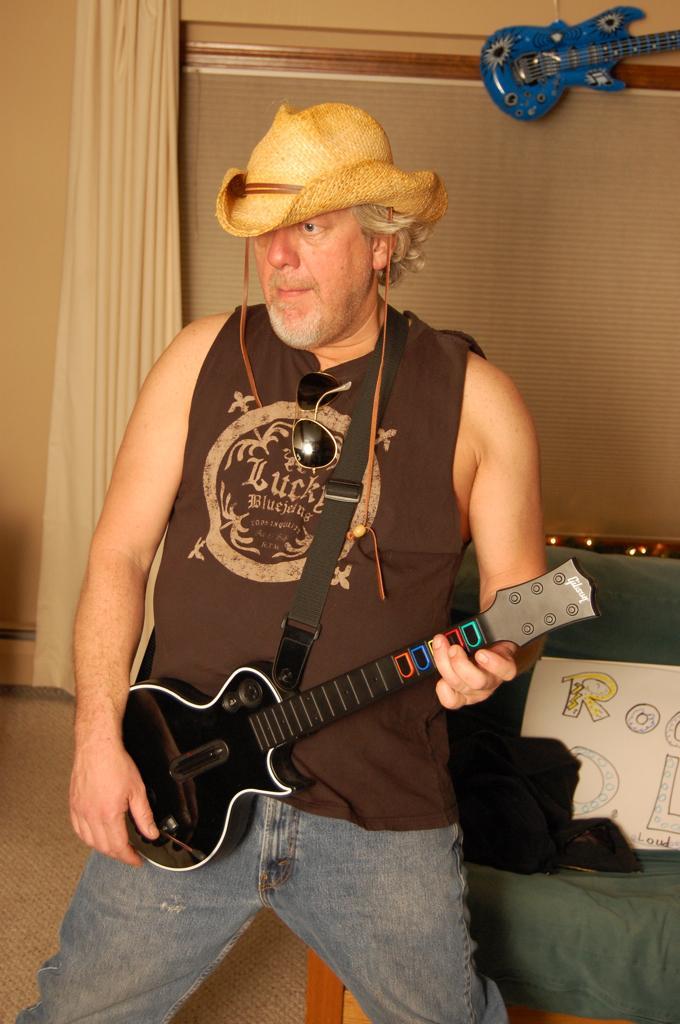Describe this image in one or two sentences. In this picture the man is holding a guitar with his left hand and he is wearing a cap 